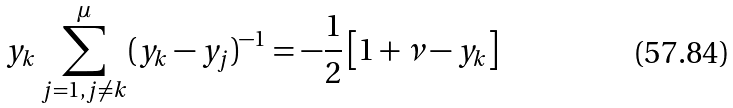<formula> <loc_0><loc_0><loc_500><loc_500>y _ { k } \sum _ { j = 1 , j \neq k } ^ { \mu } ( y _ { k } - y _ { j } ) ^ { - 1 } = - \frac { 1 } { 2 } \left [ 1 + \nu - y _ { k } \right ]</formula> 